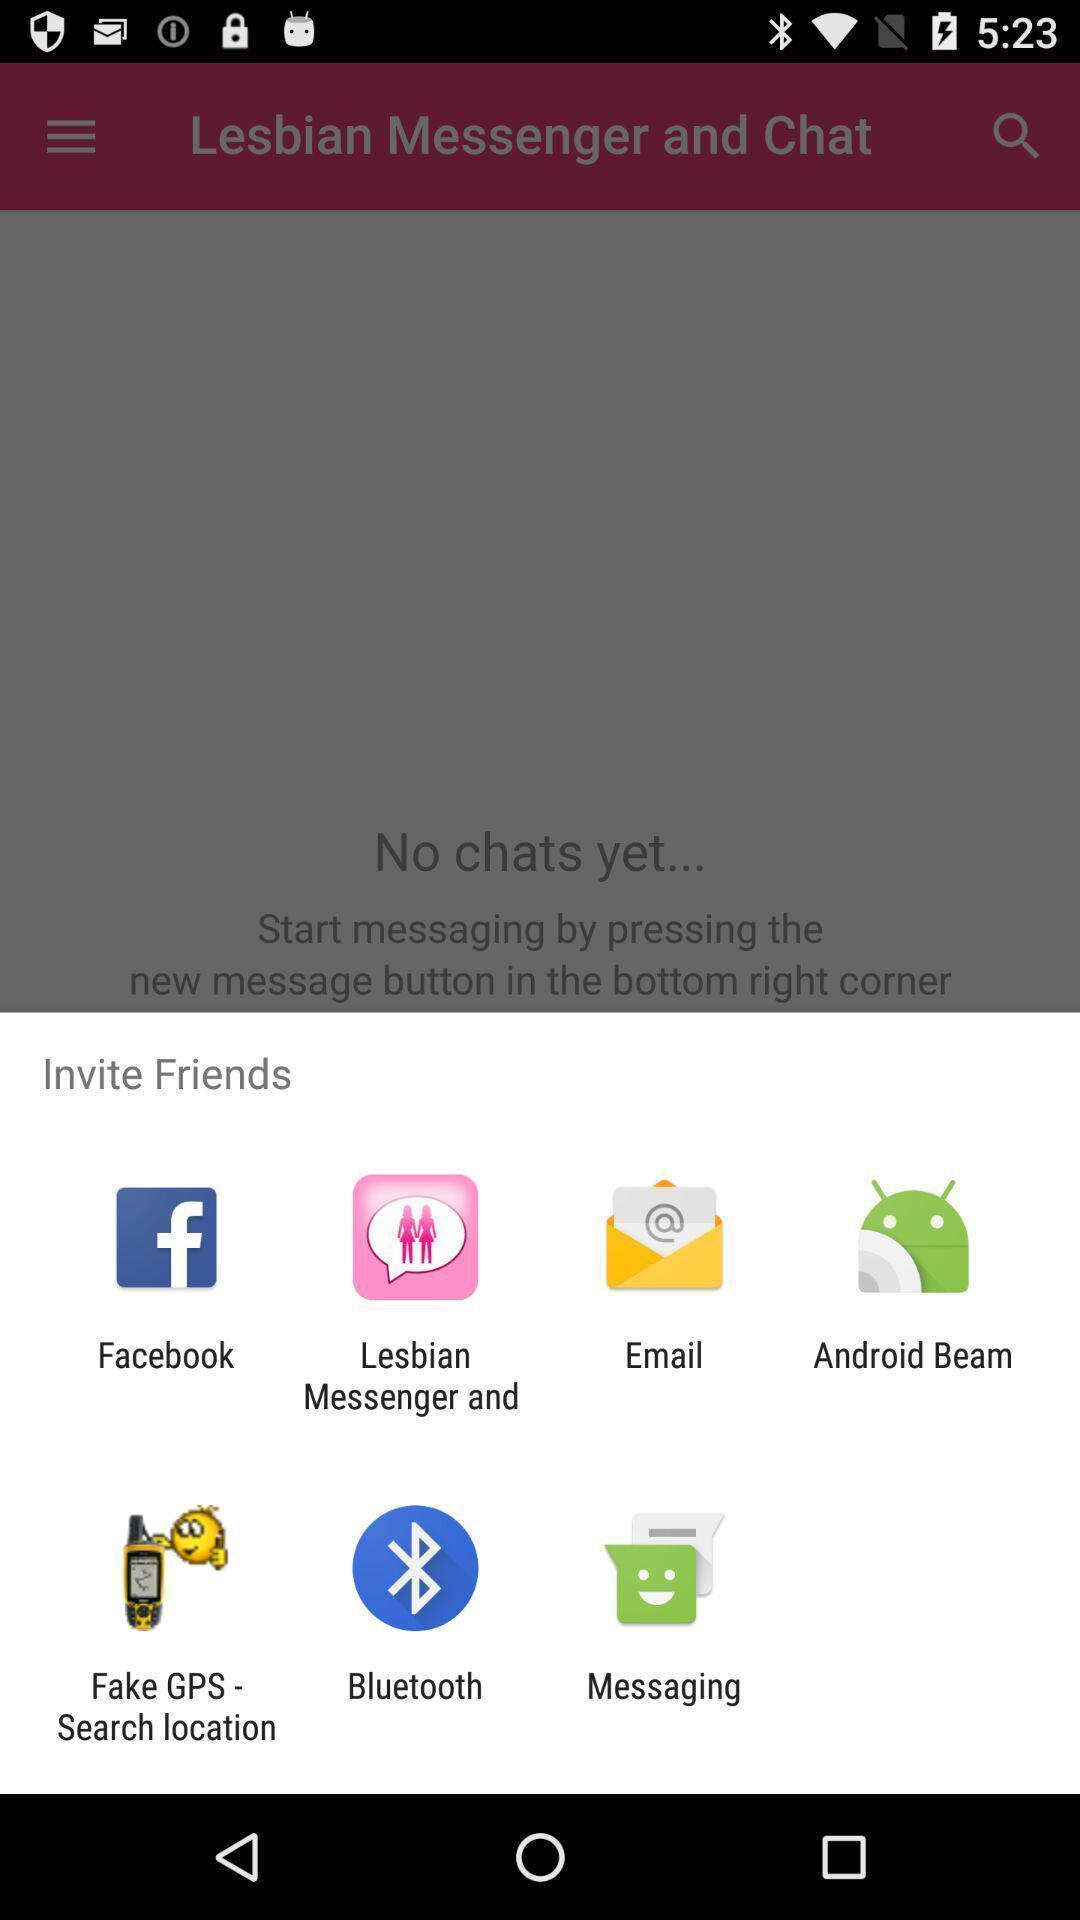Describe this image in words. Popup to invite using options in the social media app. 